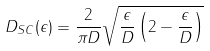Convert formula to latex. <formula><loc_0><loc_0><loc_500><loc_500>D _ { S C } ( \epsilon ) = \frac { 2 } { \pi D } \sqrt { \frac { \epsilon } { D } \left ( 2 - \frac { \epsilon } { D } \right ) }</formula> 